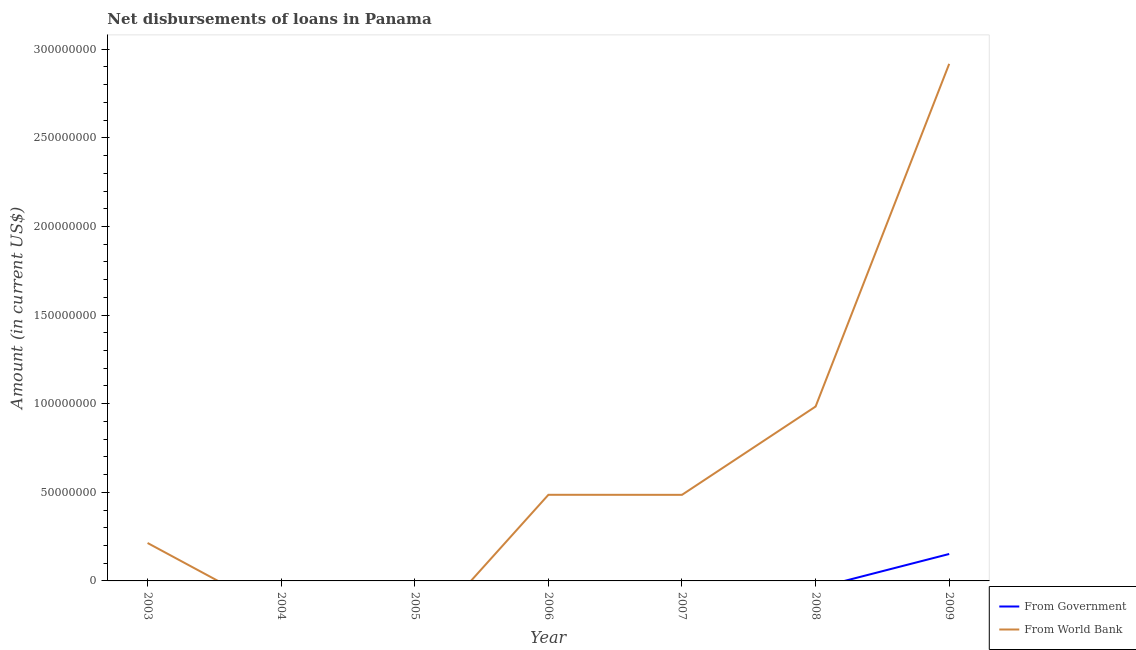How many different coloured lines are there?
Offer a very short reply. 2. Is the number of lines equal to the number of legend labels?
Your response must be concise. No. What is the net disbursements of loan from world bank in 2008?
Offer a terse response. 9.84e+07. Across all years, what is the maximum net disbursements of loan from government?
Provide a short and direct response. 1.52e+07. What is the total net disbursements of loan from world bank in the graph?
Your answer should be compact. 5.09e+08. What is the difference between the net disbursements of loan from world bank in 2007 and that in 2009?
Ensure brevity in your answer.  -2.43e+08. What is the difference between the net disbursements of loan from world bank in 2006 and the net disbursements of loan from government in 2007?
Make the answer very short. 4.86e+07. What is the average net disbursements of loan from world bank per year?
Provide a short and direct response. 7.27e+07. In how many years, is the net disbursements of loan from world bank greater than 190000000 US$?
Give a very brief answer. 1. What is the difference between the highest and the second highest net disbursements of loan from world bank?
Offer a very short reply. 1.93e+08. What is the difference between the highest and the lowest net disbursements of loan from world bank?
Provide a succinct answer. 2.92e+08. In how many years, is the net disbursements of loan from world bank greater than the average net disbursements of loan from world bank taken over all years?
Keep it short and to the point. 2. Is the sum of the net disbursements of loan from world bank in 2008 and 2009 greater than the maximum net disbursements of loan from government across all years?
Make the answer very short. Yes. What is the difference between two consecutive major ticks on the Y-axis?
Keep it short and to the point. 5.00e+07. Does the graph contain grids?
Provide a succinct answer. No. How are the legend labels stacked?
Make the answer very short. Vertical. What is the title of the graph?
Your response must be concise. Net disbursements of loans in Panama. Does "Primary" appear as one of the legend labels in the graph?
Provide a succinct answer. No. What is the label or title of the Y-axis?
Your response must be concise. Amount (in current US$). What is the Amount (in current US$) in From World Bank in 2003?
Make the answer very short. 2.14e+07. What is the Amount (in current US$) of From Government in 2004?
Provide a short and direct response. 0. What is the Amount (in current US$) in From World Bank in 2006?
Ensure brevity in your answer.  4.86e+07. What is the Amount (in current US$) of From Government in 2007?
Your answer should be very brief. 0. What is the Amount (in current US$) of From World Bank in 2007?
Your answer should be compact. 4.86e+07. What is the Amount (in current US$) of From Government in 2008?
Provide a succinct answer. 0. What is the Amount (in current US$) of From World Bank in 2008?
Your answer should be very brief. 9.84e+07. What is the Amount (in current US$) in From Government in 2009?
Ensure brevity in your answer.  1.52e+07. What is the Amount (in current US$) in From World Bank in 2009?
Give a very brief answer. 2.92e+08. Across all years, what is the maximum Amount (in current US$) in From Government?
Offer a very short reply. 1.52e+07. Across all years, what is the maximum Amount (in current US$) of From World Bank?
Make the answer very short. 2.92e+08. Across all years, what is the minimum Amount (in current US$) of From World Bank?
Ensure brevity in your answer.  0. What is the total Amount (in current US$) in From Government in the graph?
Provide a short and direct response. 1.52e+07. What is the total Amount (in current US$) in From World Bank in the graph?
Provide a succinct answer. 5.09e+08. What is the difference between the Amount (in current US$) of From World Bank in 2003 and that in 2006?
Give a very brief answer. -2.72e+07. What is the difference between the Amount (in current US$) of From World Bank in 2003 and that in 2007?
Give a very brief answer. -2.72e+07. What is the difference between the Amount (in current US$) in From World Bank in 2003 and that in 2008?
Provide a short and direct response. -7.70e+07. What is the difference between the Amount (in current US$) in From World Bank in 2003 and that in 2009?
Offer a terse response. -2.70e+08. What is the difference between the Amount (in current US$) in From World Bank in 2006 and that in 2008?
Your answer should be very brief. -4.98e+07. What is the difference between the Amount (in current US$) in From World Bank in 2006 and that in 2009?
Your answer should be compact. -2.43e+08. What is the difference between the Amount (in current US$) of From World Bank in 2007 and that in 2008?
Ensure brevity in your answer.  -4.98e+07. What is the difference between the Amount (in current US$) in From World Bank in 2007 and that in 2009?
Offer a terse response. -2.43e+08. What is the difference between the Amount (in current US$) of From World Bank in 2008 and that in 2009?
Your answer should be very brief. -1.93e+08. What is the average Amount (in current US$) of From Government per year?
Your answer should be very brief. 2.17e+06. What is the average Amount (in current US$) in From World Bank per year?
Provide a succinct answer. 7.27e+07. In the year 2009, what is the difference between the Amount (in current US$) of From Government and Amount (in current US$) of From World Bank?
Your answer should be very brief. -2.77e+08. What is the ratio of the Amount (in current US$) of From World Bank in 2003 to that in 2006?
Offer a terse response. 0.44. What is the ratio of the Amount (in current US$) in From World Bank in 2003 to that in 2007?
Keep it short and to the point. 0.44. What is the ratio of the Amount (in current US$) of From World Bank in 2003 to that in 2008?
Give a very brief answer. 0.22. What is the ratio of the Amount (in current US$) of From World Bank in 2003 to that in 2009?
Give a very brief answer. 0.07. What is the ratio of the Amount (in current US$) of From World Bank in 2006 to that in 2008?
Offer a terse response. 0.49. What is the ratio of the Amount (in current US$) in From World Bank in 2006 to that in 2009?
Give a very brief answer. 0.17. What is the ratio of the Amount (in current US$) of From World Bank in 2007 to that in 2008?
Ensure brevity in your answer.  0.49. What is the ratio of the Amount (in current US$) of From World Bank in 2007 to that in 2009?
Offer a very short reply. 0.17. What is the ratio of the Amount (in current US$) in From World Bank in 2008 to that in 2009?
Provide a succinct answer. 0.34. What is the difference between the highest and the second highest Amount (in current US$) in From World Bank?
Keep it short and to the point. 1.93e+08. What is the difference between the highest and the lowest Amount (in current US$) in From Government?
Provide a short and direct response. 1.52e+07. What is the difference between the highest and the lowest Amount (in current US$) in From World Bank?
Offer a very short reply. 2.92e+08. 